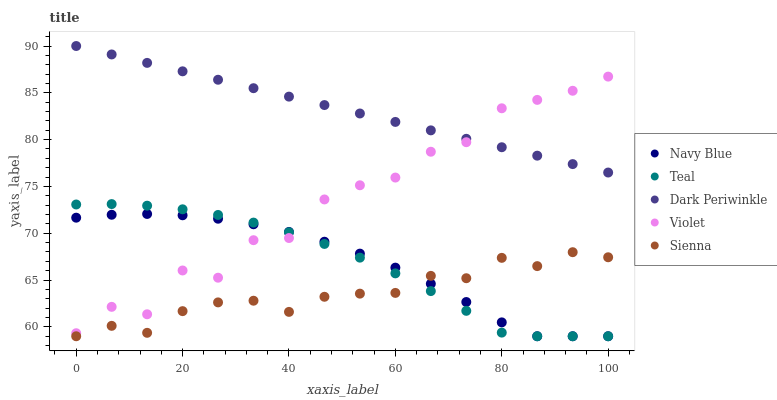Does Sienna have the minimum area under the curve?
Answer yes or no. Yes. Does Dark Periwinkle have the maximum area under the curve?
Answer yes or no. Yes. Does Navy Blue have the minimum area under the curve?
Answer yes or no. No. Does Navy Blue have the maximum area under the curve?
Answer yes or no. No. Is Dark Periwinkle the smoothest?
Answer yes or no. Yes. Is Violet the roughest?
Answer yes or no. Yes. Is Navy Blue the smoothest?
Answer yes or no. No. Is Navy Blue the roughest?
Answer yes or no. No. Does Sienna have the lowest value?
Answer yes or no. Yes. Does Dark Periwinkle have the lowest value?
Answer yes or no. No. Does Dark Periwinkle have the highest value?
Answer yes or no. Yes. Does Navy Blue have the highest value?
Answer yes or no. No. Is Navy Blue less than Dark Periwinkle?
Answer yes or no. Yes. Is Dark Periwinkle greater than Navy Blue?
Answer yes or no. Yes. Does Violet intersect Teal?
Answer yes or no. Yes. Is Violet less than Teal?
Answer yes or no. No. Is Violet greater than Teal?
Answer yes or no. No. Does Navy Blue intersect Dark Periwinkle?
Answer yes or no. No. 